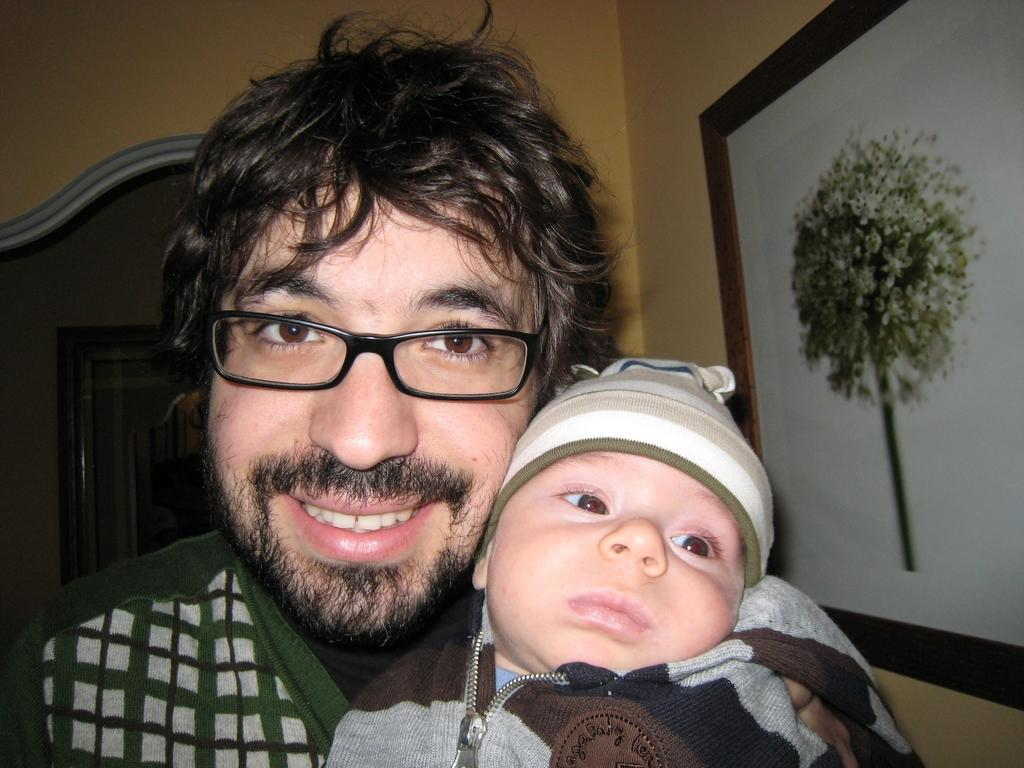Who is present in the image? There is a man in the image. What is the man's facial expression? The man is smiling. Can you describe the possible interaction between the man and another person or object in the image? The man may be holding a baby. How is the image displayed? The image appears to be in a photo frame, which is attached to a wall. What architectural feature can be seen in the background of the image? There is an arch in the background of the image. What type of shock can be seen in the image? There is no shock present in the image; it features a smiling man who may be holding a baby. What level of control does the man have over the situation in the image? The image does not provide enough information to determine the level of control the man has over the situation. 